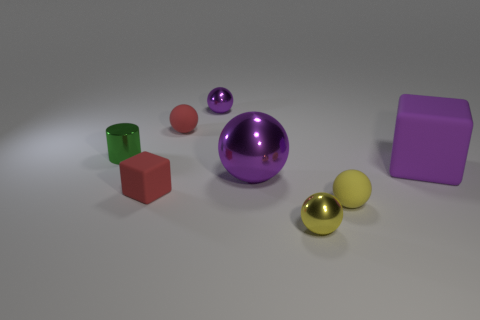Is there any pattern in how the objects are arranged on the surface? There doesn't seem to be a specific pattern in the arrangement of the objects. They are placed on the surface at varying distances from each other without a discernible order or sequence. 